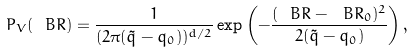<formula> <loc_0><loc_0><loc_500><loc_500>P _ { V } ( \ B R ) = \frac { 1 } { ( 2 \pi ( \tilde { q } - q _ { 0 } ) ) ^ { d / 2 } } \exp \left ( - \frac { ( \ B R - \ B R _ { 0 } ) ^ { 2 } } { 2 ( \tilde { q } - q _ { 0 } ) } \right ) ,</formula> 